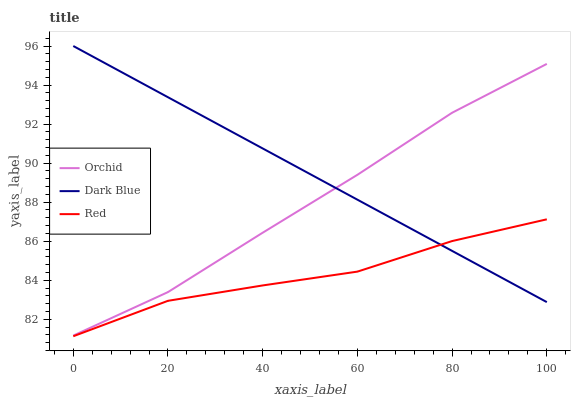Does Red have the minimum area under the curve?
Answer yes or no. Yes. Does Dark Blue have the maximum area under the curve?
Answer yes or no. Yes. Does Orchid have the minimum area under the curve?
Answer yes or no. No. Does Orchid have the maximum area under the curve?
Answer yes or no. No. Is Dark Blue the smoothest?
Answer yes or no. Yes. Is Red the roughest?
Answer yes or no. Yes. Is Orchid the smoothest?
Answer yes or no. No. Is Orchid the roughest?
Answer yes or no. No. Does Red have the lowest value?
Answer yes or no. Yes. Does Orchid have the lowest value?
Answer yes or no. No. Does Dark Blue have the highest value?
Answer yes or no. Yes. Does Orchid have the highest value?
Answer yes or no. No. Is Red less than Orchid?
Answer yes or no. Yes. Is Orchid greater than Red?
Answer yes or no. Yes. Does Orchid intersect Dark Blue?
Answer yes or no. Yes. Is Orchid less than Dark Blue?
Answer yes or no. No. Is Orchid greater than Dark Blue?
Answer yes or no. No. Does Red intersect Orchid?
Answer yes or no. No. 